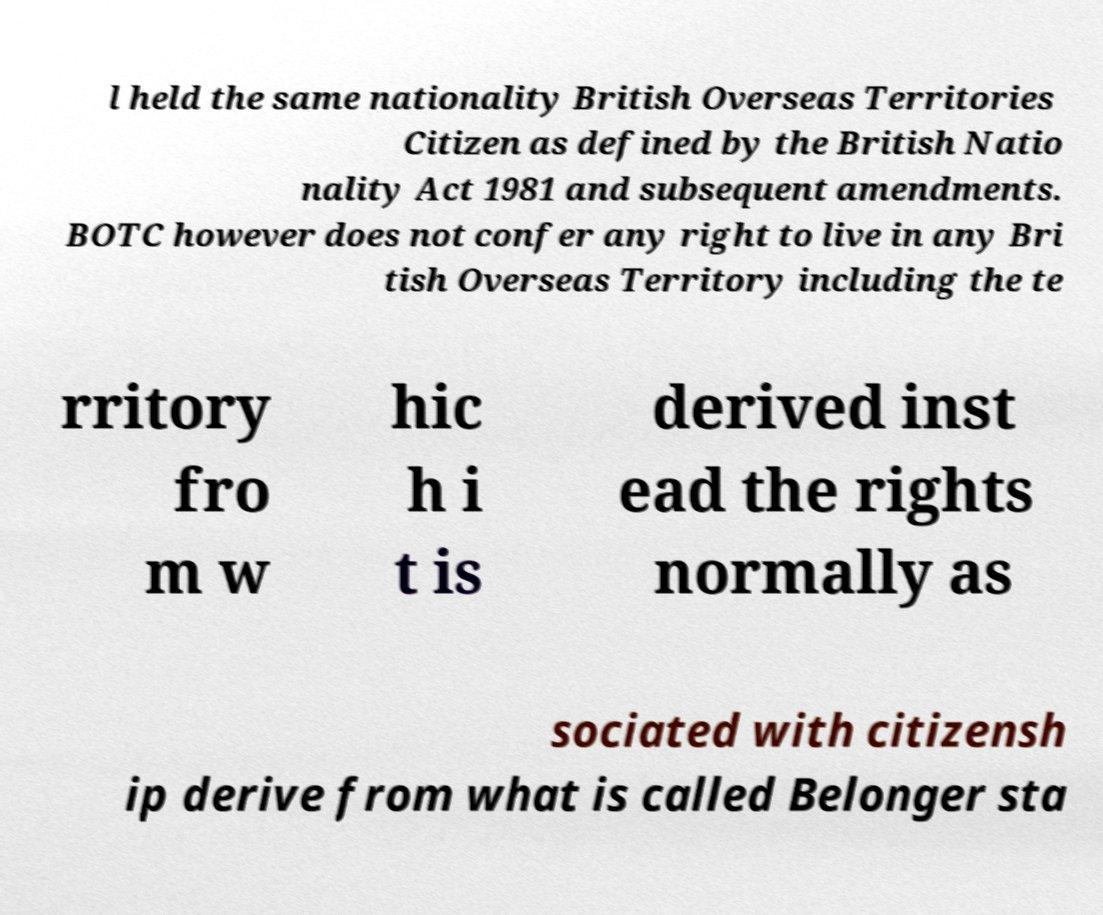Could you extract and type out the text from this image? l held the same nationality British Overseas Territories Citizen as defined by the British Natio nality Act 1981 and subsequent amendments. BOTC however does not confer any right to live in any Bri tish Overseas Territory including the te rritory fro m w hic h i t is derived inst ead the rights normally as sociated with citizensh ip derive from what is called Belonger sta 